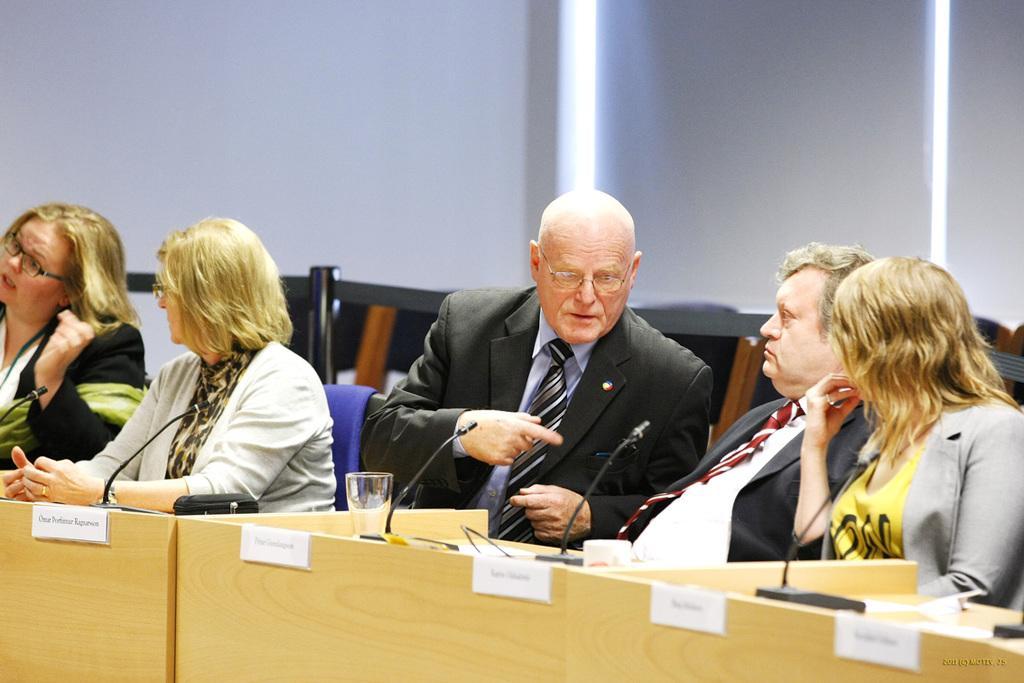Can you describe this image briefly? In this picture we can see five people sitting on the chair. There are microphones, glass and a wallet is visible on a wooden table. We can see a few white papers on a wooden desk and some text is written in thesis papers. There is a watermark in the bottom right. We can see lights in the background. 